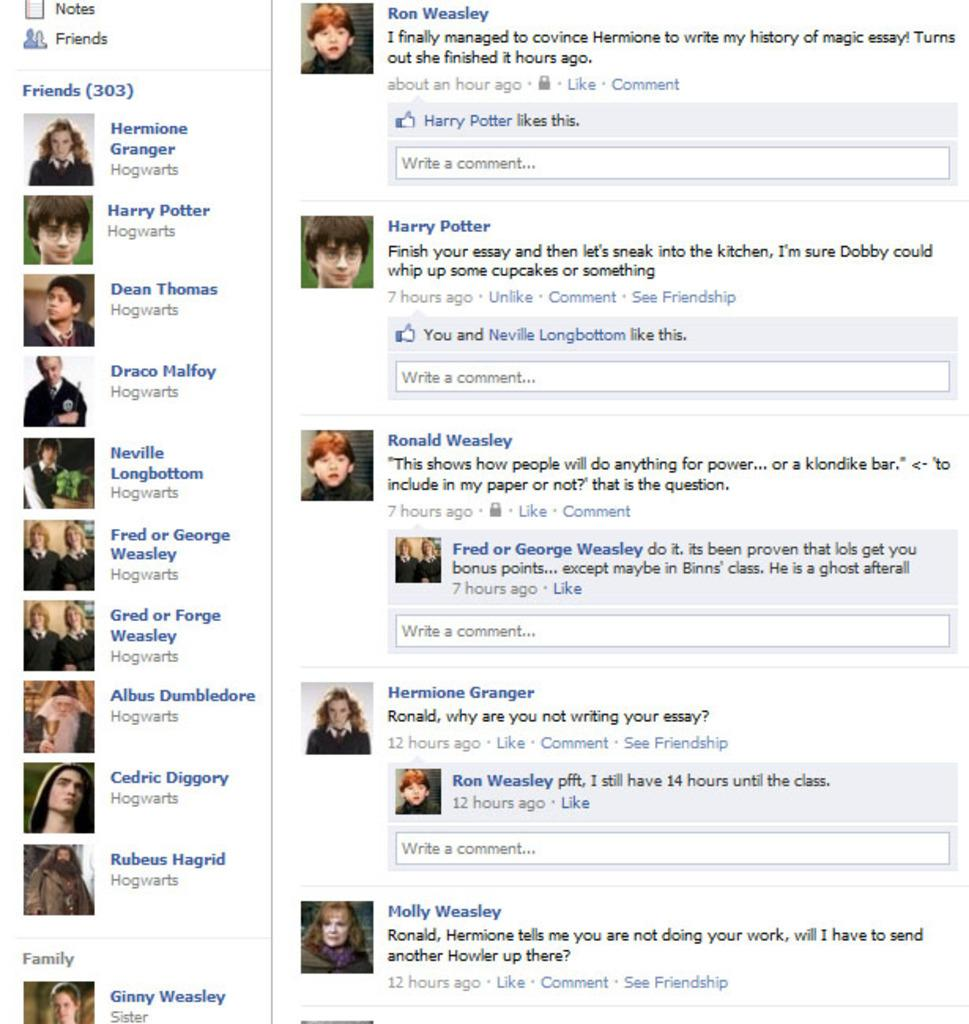What is featured in the image? There is a poster in the image. What can be found on the poster? The poster includes text and images. What type of branch is shown in the image? There is no branch present in the image; it features a poster with text and images. 